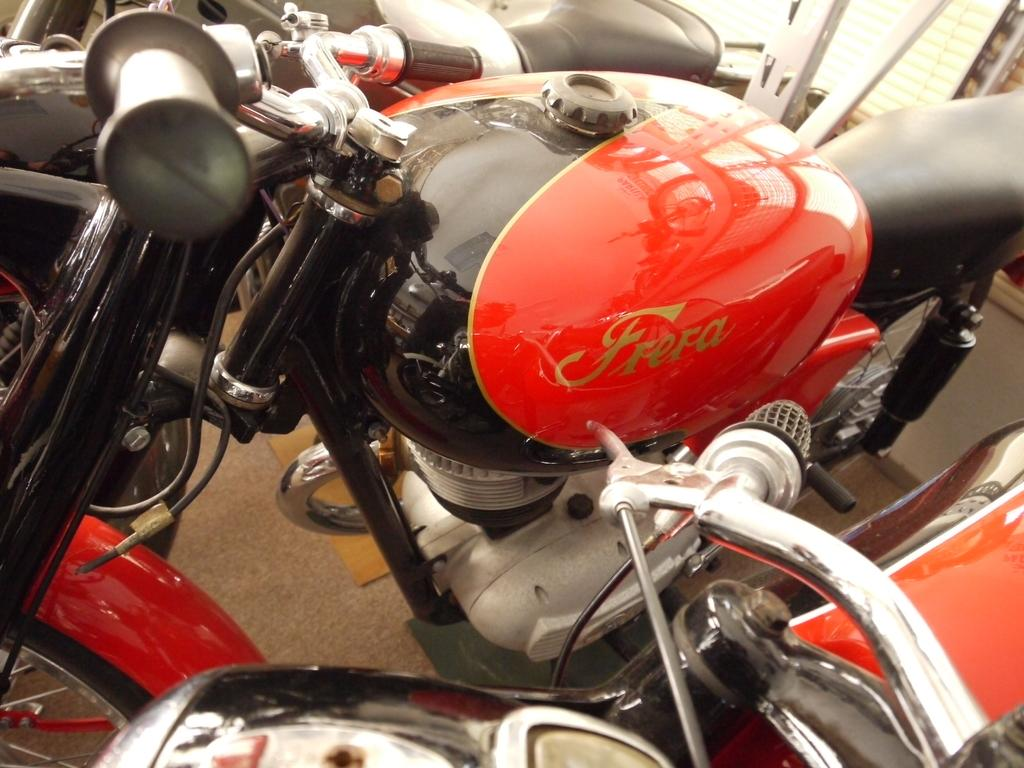What can be seen on the road in the image? There are vehicles on the road in the image. What objects are located in the top right corner of the image? There are metal rods in the top right corner of the image. What type of structure is visible in the image? There is a wall with a window in the image. How is the window covered in the image? The window has a window blind covering it. What type of lamp is present in the image? A: There is no lamp present in the image. What things are being competed in the image? The image does not depict any competition or competitive activity. 